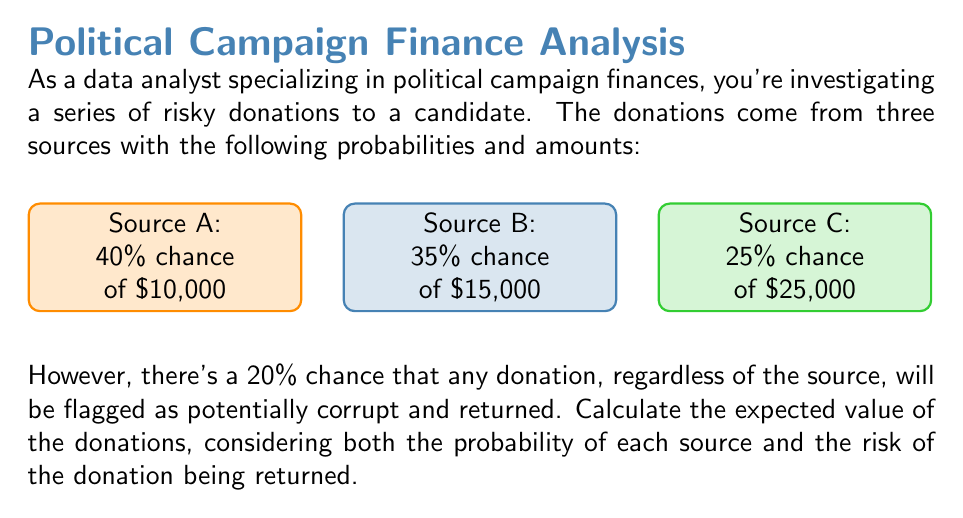What is the answer to this math problem? Let's approach this step-by-step:

1) First, we need to calculate the expected value of each source without considering the risk of return:

   Source A: $E(A) = 0.40 \times \$10,000 = \$4,000$
   Source B: $E(B) = 0.35 \times \$15,000 = \$5,250$
   Source C: $E(C) = 0.25 \times \$25,000 = \$6,250$

2) The total expected value without considering the risk is:
   
   $E(\text{total}) = E(A) + E(B) + E(C) = \$4,000 + \$5,250 + \$6,250 = \$15,500$

3) Now, we need to consider the 20% chance of any donation being returned. This means there's an 80% chance of keeping the donation.

4) We can apply this probability to our total expected value:

   $E(\text{final}) = 0.80 \times E(\text{total})$

5) Plugging in the numbers:

   $E(\text{final}) = 0.80 \times \$15,500 = \$12,400$

Therefore, the expected value of the donations, considering both the probability of each source and the risk of return, is $12,400.
Answer: $12,400 